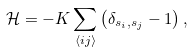Convert formula to latex. <formula><loc_0><loc_0><loc_500><loc_500>\mathcal { H } = - K \sum _ { \langle i j \rangle } \left ( \delta _ { s _ { i } , s _ { j } } - 1 \right ) ,</formula> 